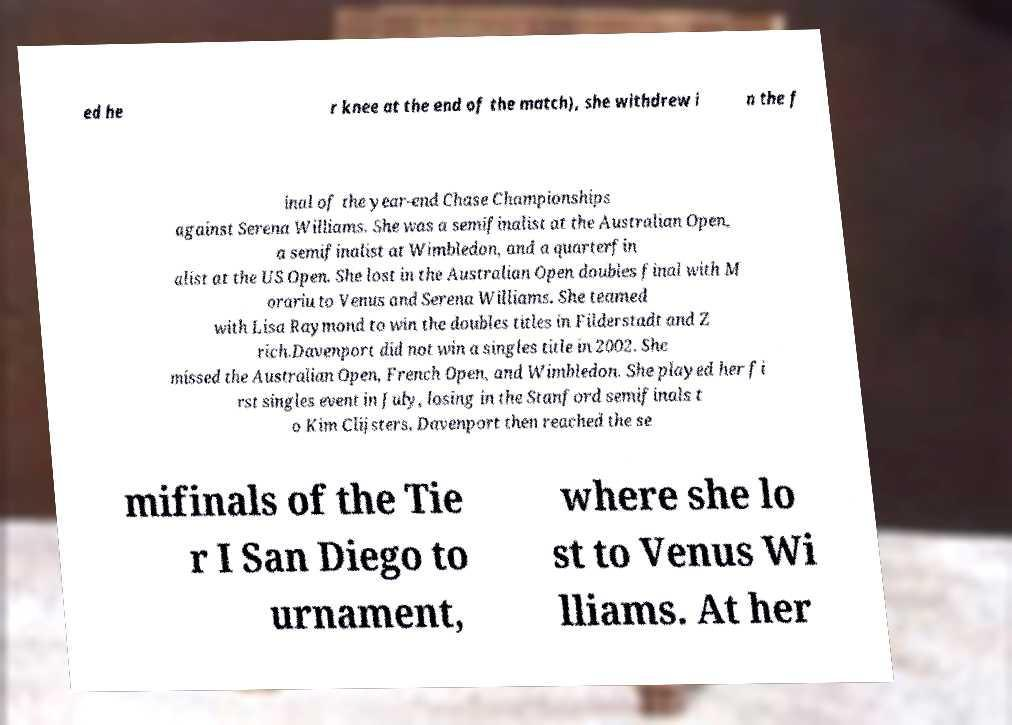There's text embedded in this image that I need extracted. Can you transcribe it verbatim? ed he r knee at the end of the match), she withdrew i n the f inal of the year-end Chase Championships against Serena Williams. She was a semifinalist at the Australian Open, a semifinalist at Wimbledon, and a quarterfin alist at the US Open. She lost in the Australian Open doubles final with M orariu to Venus and Serena Williams. She teamed with Lisa Raymond to win the doubles titles in Filderstadt and Z rich.Davenport did not win a singles title in 2002. She missed the Australian Open, French Open, and Wimbledon. She played her fi rst singles event in July, losing in the Stanford semifinals t o Kim Clijsters. Davenport then reached the se mifinals of the Tie r I San Diego to urnament, where she lo st to Venus Wi lliams. At her 